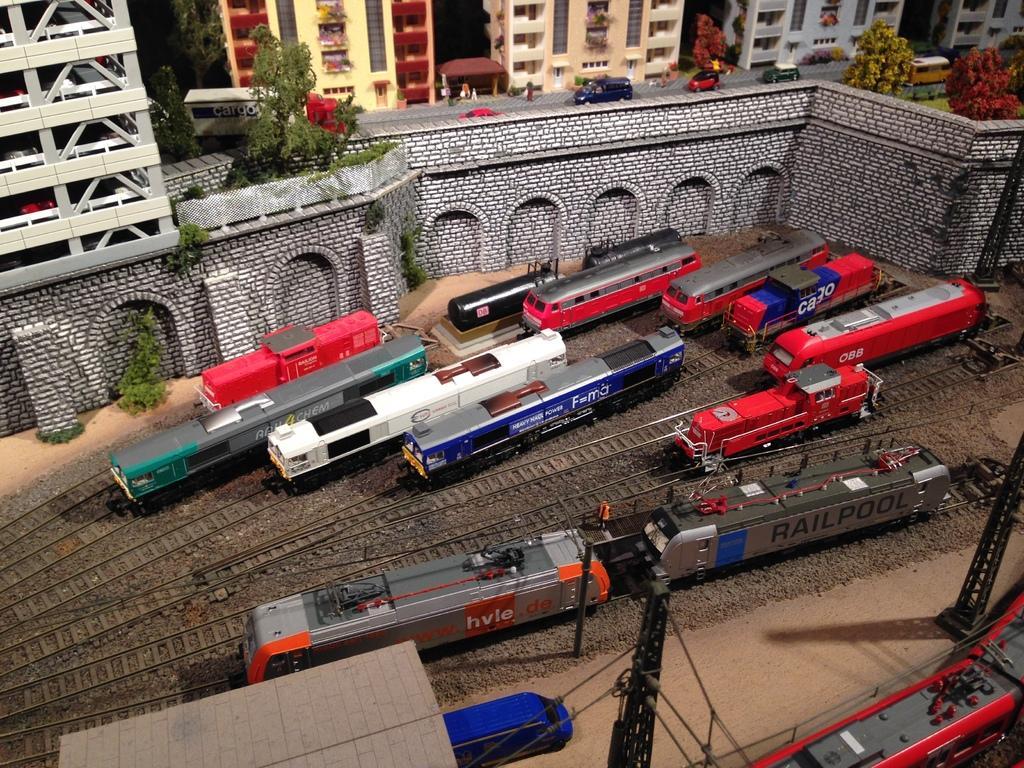Can you describe this image briefly? In this picture there are railway tracks, trains, poles, cables and platform. At the top there are buildings, trees, vehicles and a wall. 